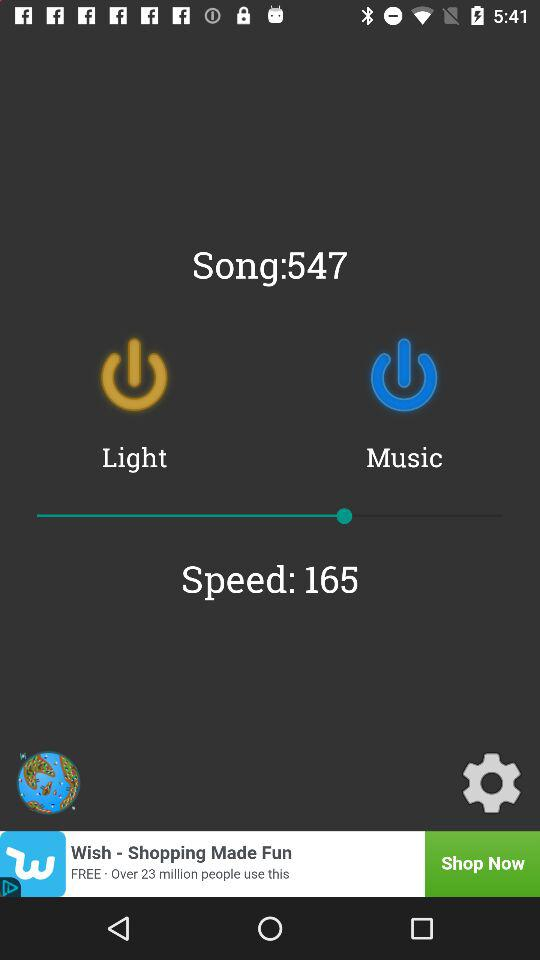What is the number of the song? The number of the song is 547. 